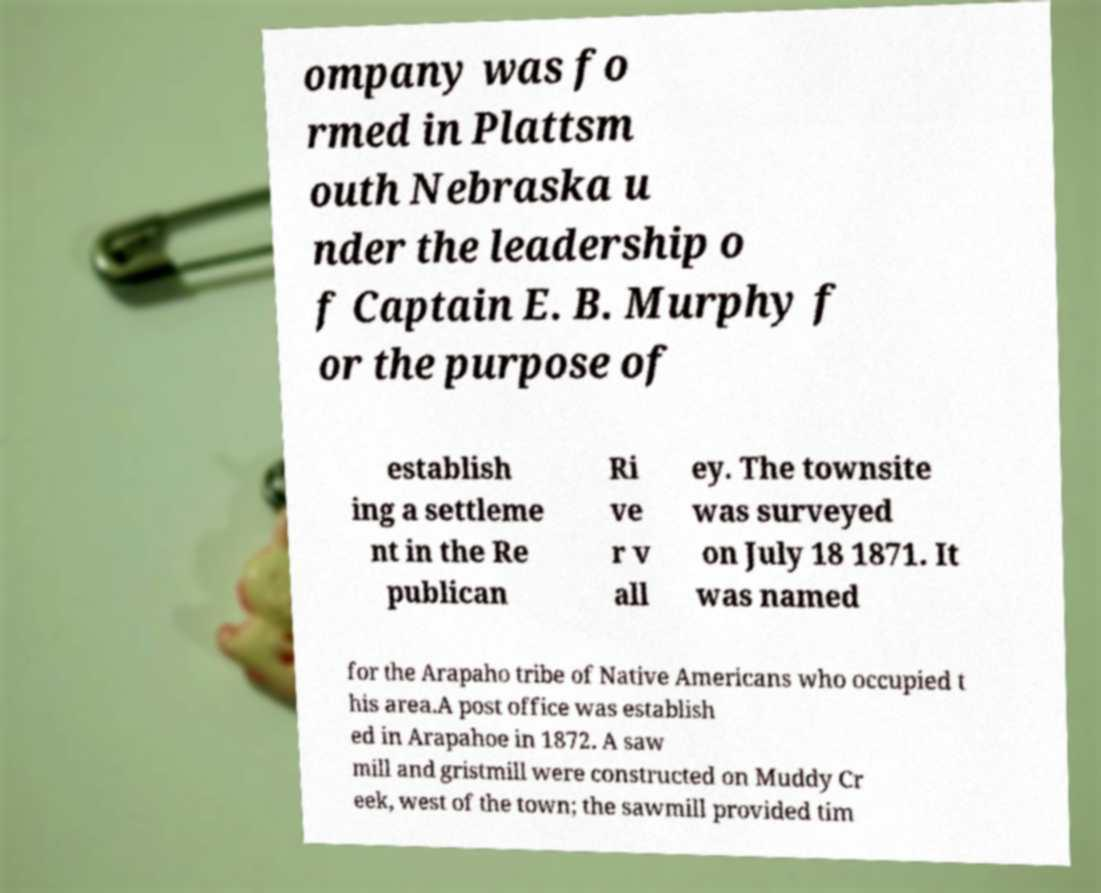What messages or text are displayed in this image? I need them in a readable, typed format. ompany was fo rmed in Plattsm outh Nebraska u nder the leadership o f Captain E. B. Murphy f or the purpose of establish ing a settleme nt in the Re publican Ri ve r v all ey. The townsite was surveyed on July 18 1871. It was named for the Arapaho tribe of Native Americans who occupied t his area.A post office was establish ed in Arapahoe in 1872. A saw mill and gristmill were constructed on Muddy Cr eek, west of the town; the sawmill provided tim 